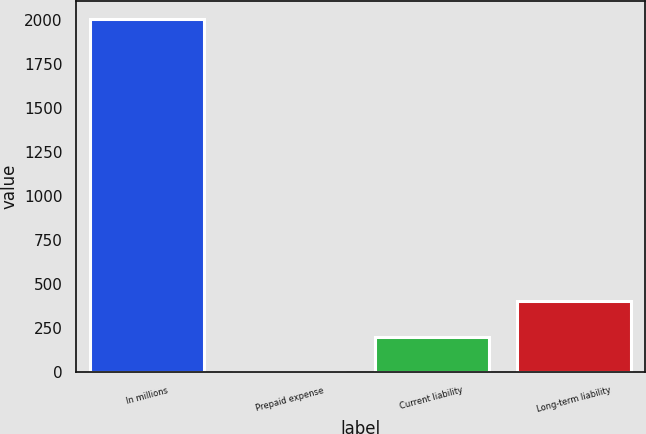Convert chart to OTSL. <chart><loc_0><loc_0><loc_500><loc_500><bar_chart><fcel>In millions<fcel>Prepaid expense<fcel>Current liability<fcel>Long-term liability<nl><fcel>2009<fcel>2.5<fcel>203.15<fcel>403.8<nl></chart> 